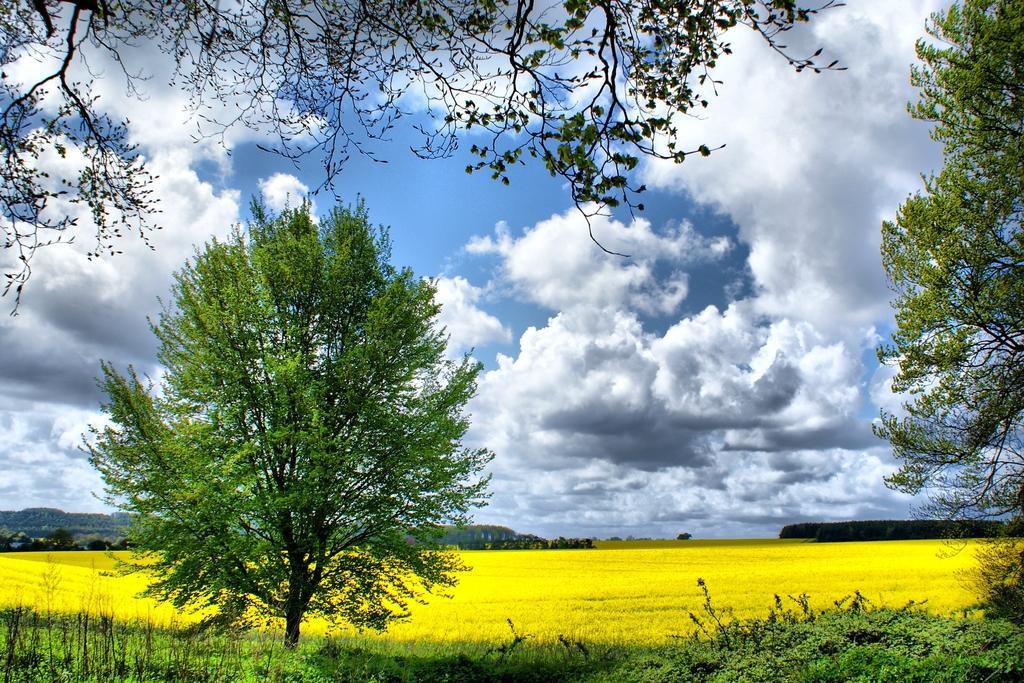Describe this image in one or two sentences. In this picture we can see trees, grass and in the background we can see the sky with clouds. 